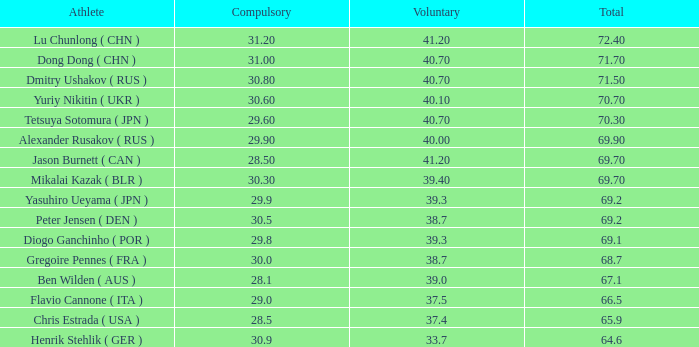What's the position that has a total less than 66.5m, a compulsory of 30.9 and voluntary less than 33.7? None. 